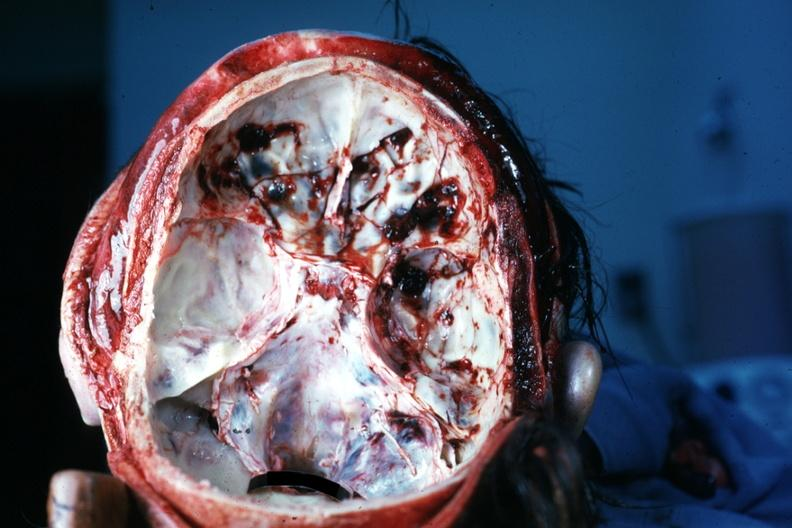s fibroma present?
Answer the question using a single word or phrase. No 